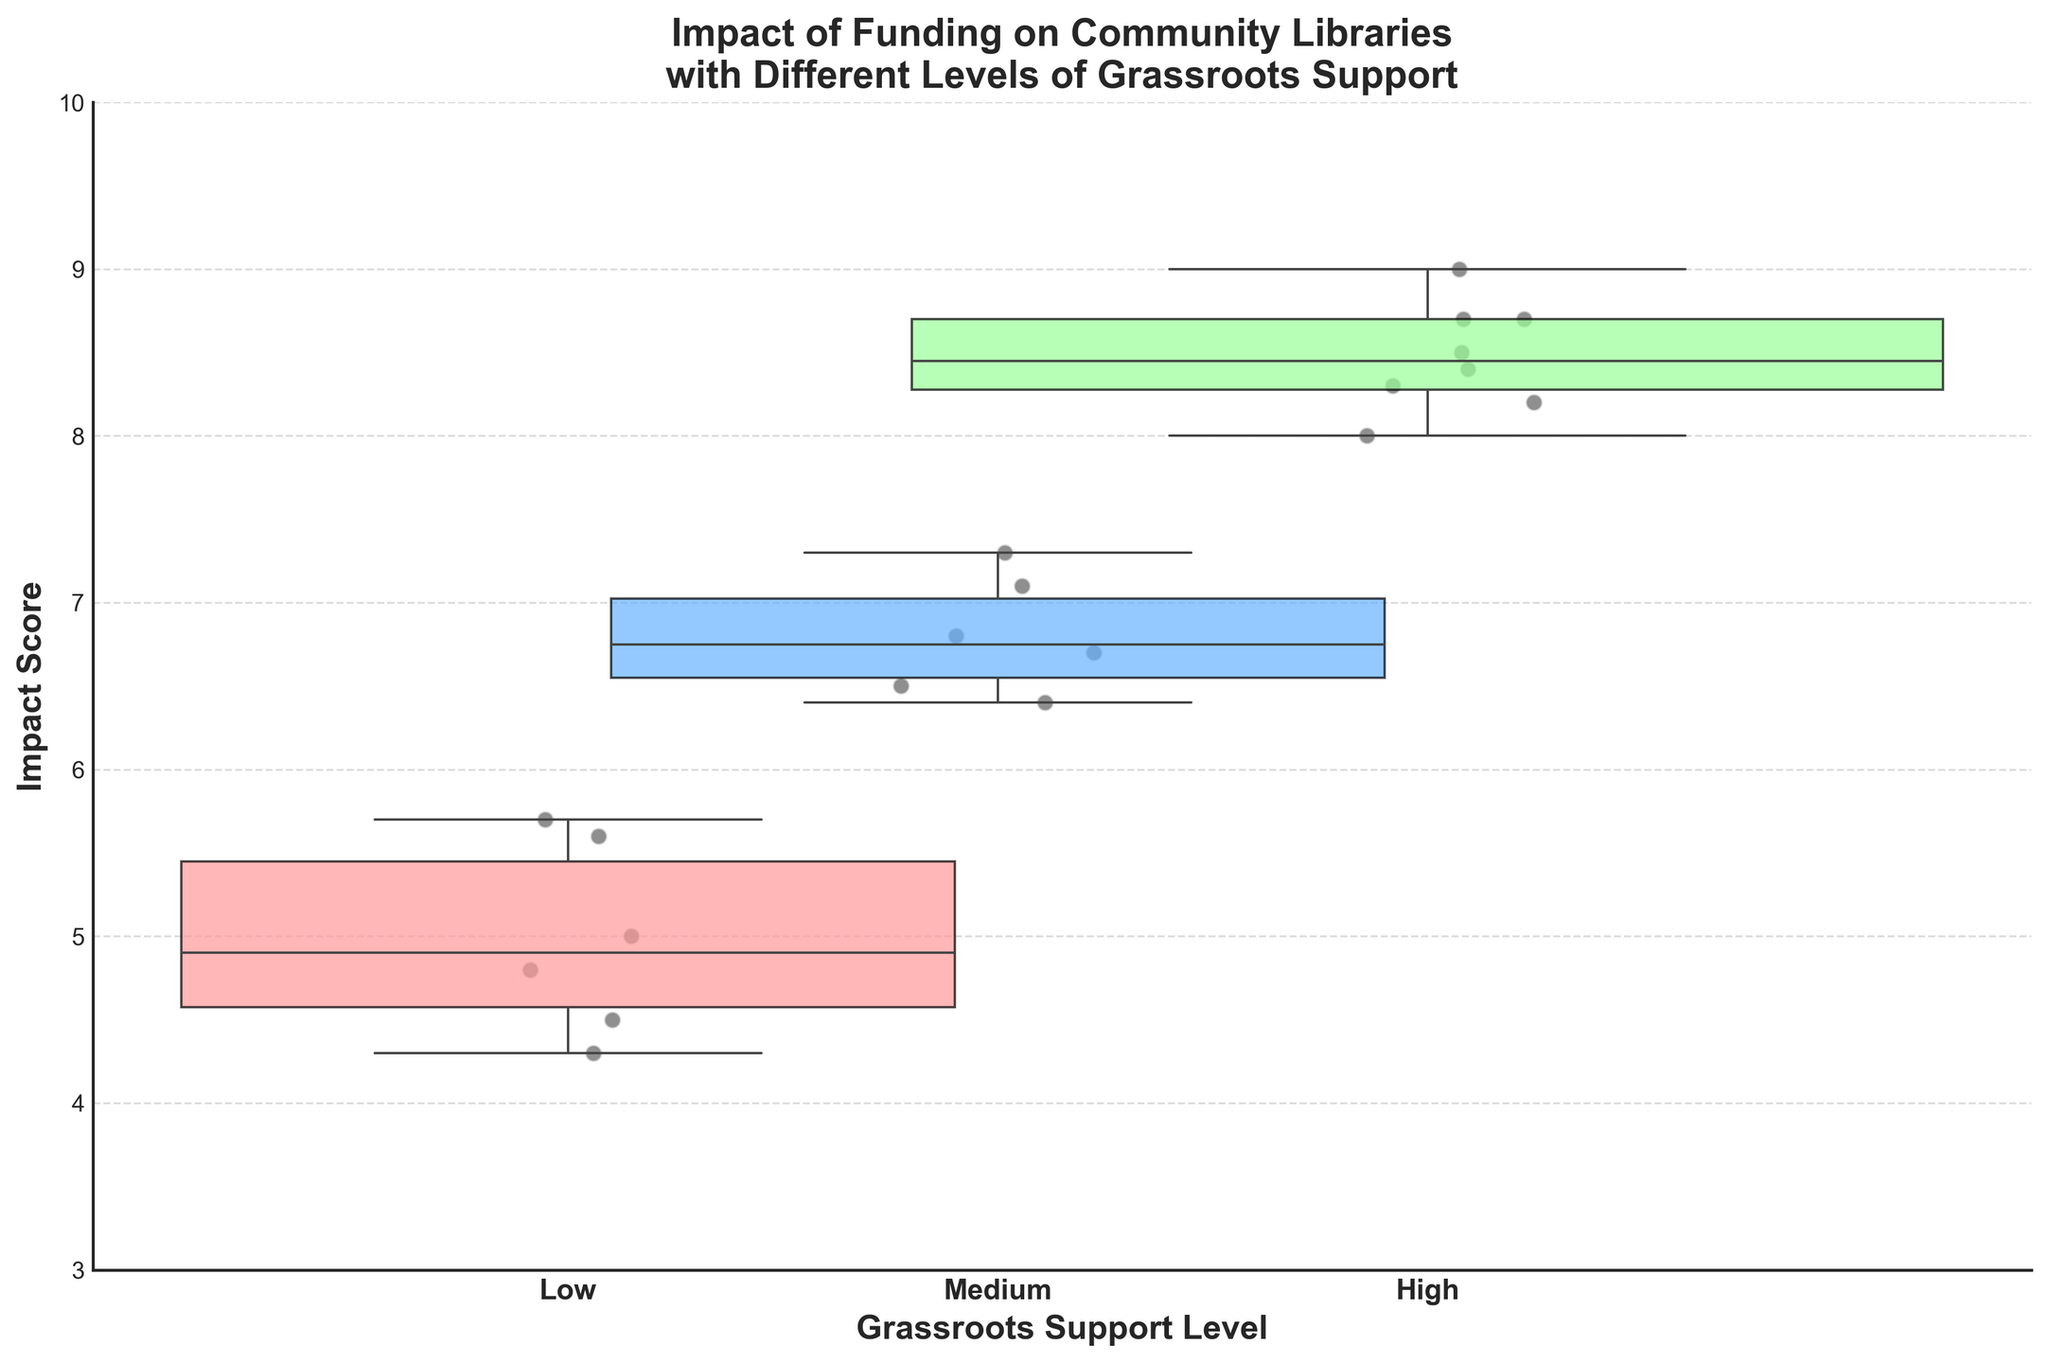What is the title of the plot? The title is positioned at the top of the plot. It reads "Impact of Funding on Community Libraries\nwith Different Levels of Grassroots Support".
Answer: Impact of Funding on Community Libraries\nwith Different Levels of Grassroots Support How many levels of grassroots support are illustrated in the plot? The x-axis labels represent the grassroots support levels: Low, Medium, and High. There are three levels indicated.
Answer: Three Which level of grassroots support has the widest box plot width? The width of the box plots corresponds to the number of data points in each category. The box plot for the "High" support level is visibly the widest.
Answer: High What are the median Impact Scores for each grassroots support level? By examining the line within each box, the medians can be observed. For Low, the median is approximately 4.8, for Medium, it's around 6.7, and for High, it's about 8.4.
Answer: Low: 4.8, Medium: 6.7, High: 8.4 Which grassroots support level has the lowest Impact Score? The position of the bottom whisker represents the lowest Impact Score. The "Low" support level has the lowest score, around 4.3.
Answer: Low How do the Impact Scores for Medium and High grassroots support levels compare? Looking at the interquartile ranges, medians, and whiskers, High support has higher overall Impact Scores compared to Medium support. Medium: interquartile range 6.4-7.1 (median 6.7), High: interquartile range 8.2-8.7 (median 8.4).
Answer: High has higher Impact Scores Which grassroots support level shows the greatest variability in Impact Scores? Variability can be assessed by the range from whisker to whisker. "Medium" shows the greatest spread from around 6.4 to 7.3, indicating greater variability compared to Low and High.
Answer: Medium What can be inferred about the outliers in the box plots? Observation of scattered points outside the whiskers indicates outliers. There are no significant outliers visible for any level of grassroots support, suggesting a generally consistent data range for each category.
Answer: No significant outliers What does the color coding represent in the plot? By examining the box plot colors, we can deduce each color corresponds to different grassroots support levels: Low (light red), Medium (light blue), High (light green).
Answer: Levels of grassroots support Are there more libraries represented in High grassroots support than in Low? The width of the box plots indicates the quantity of data points. The wider width for High support implies more libraries are categorized under High support compared to Low.
Answer: Yes How does the box plot reflect the potential influence of grassroots support on Impact Scores? The rising median scores from Low to High support suggest a positive correlation. Higher grassroots support is associated with higher Impact Scores, indicating a potential influence of grassroots activity on library success.
Answer: Positive correlation 